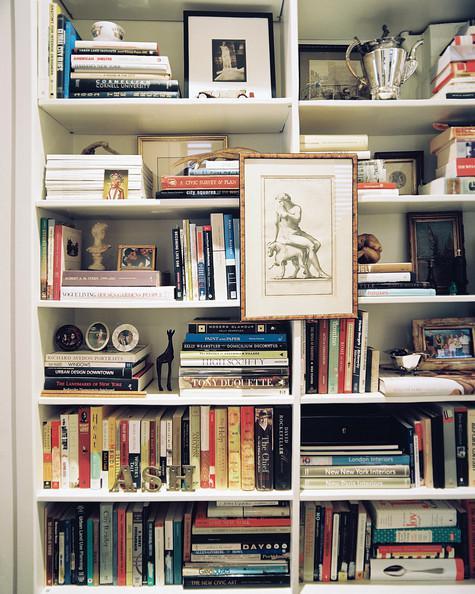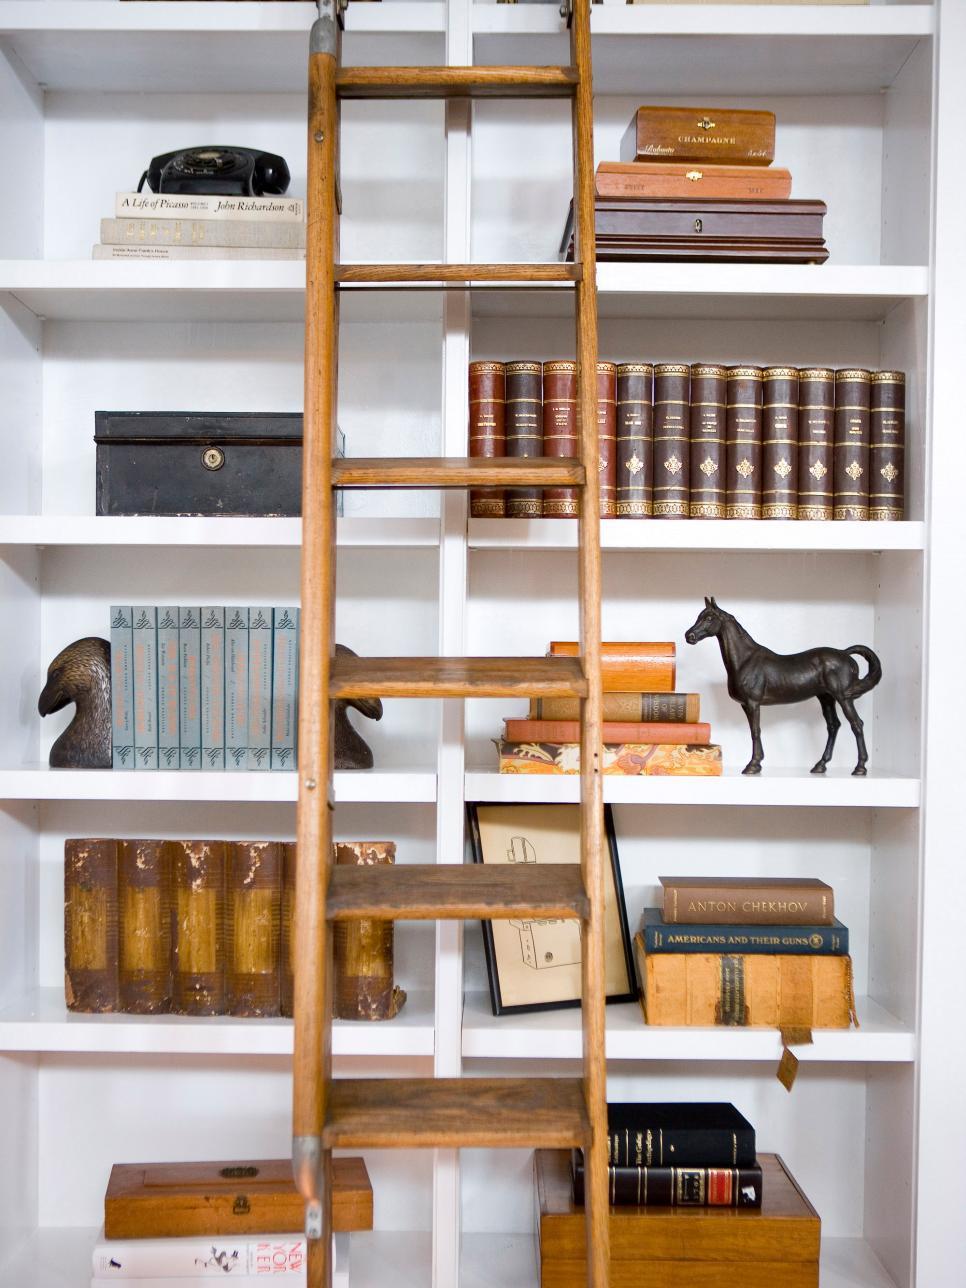The first image is the image on the left, the second image is the image on the right. Analyze the images presented: Is the assertion "The right image shows a ladder leaned up against the front of a stocked bookshelf." valid? Answer yes or no. Yes. The first image is the image on the left, the second image is the image on the right. Considering the images on both sides, is "In one image, a wall bookshelf unit with at least six shelves has at least one piece of framed artwork mounted to the front of the shelf, obscuring some of the contents." valid? Answer yes or no. Yes. 